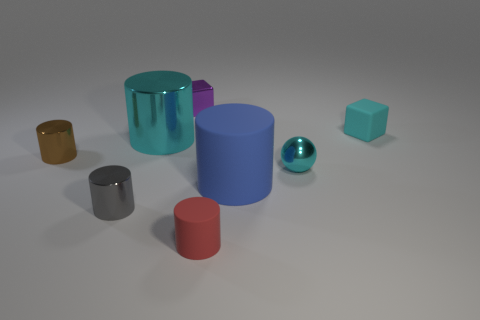Is the color of the large shiny object the same as the matte block?
Offer a very short reply. Yes. How many things are either purple metallic cubes or small brown rubber spheres?
Make the answer very short. 1. What size is the metal cylinder that is both in front of the large shiny object and behind the blue object?
Ensure brevity in your answer.  Small. What number of other gray cylinders have the same material as the tiny gray cylinder?
Your response must be concise. 0. What is the color of the tiny block that is the same material as the tiny sphere?
Your answer should be very brief. Purple. There is a tiny cube in front of the purple metallic object; does it have the same color as the big shiny object?
Keep it short and to the point. Yes. What material is the big thing that is on the left side of the small shiny cube?
Offer a terse response. Metal. Are there the same number of big rubber objects that are left of the small purple object and small shiny things?
Keep it short and to the point. No. What number of other metal balls have the same color as the sphere?
Provide a short and direct response. 0. The other big thing that is the same shape as the blue matte object is what color?
Your answer should be compact. Cyan. 